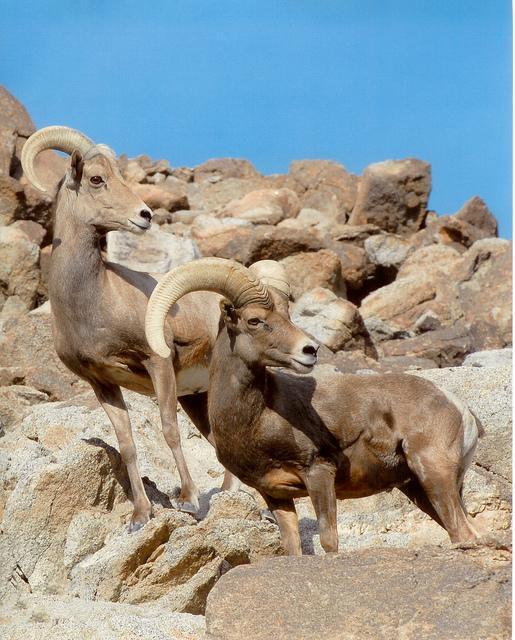How many horns?
Give a very brief answer. 4. How many sheep can you see?
Give a very brief answer. 2. How many people are holding a bat?
Give a very brief answer. 0. 